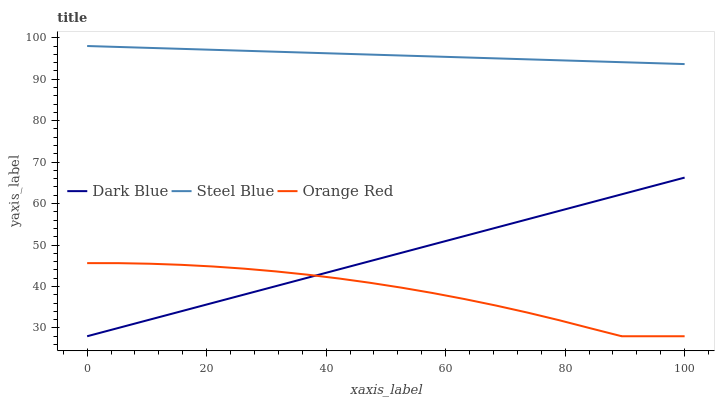Does Orange Red have the minimum area under the curve?
Answer yes or no. Yes. Does Steel Blue have the maximum area under the curve?
Answer yes or no. Yes. Does Steel Blue have the minimum area under the curve?
Answer yes or no. No. Does Orange Red have the maximum area under the curve?
Answer yes or no. No. Is Steel Blue the smoothest?
Answer yes or no. Yes. Is Orange Red the roughest?
Answer yes or no. Yes. Is Orange Red the smoothest?
Answer yes or no. No. Is Steel Blue the roughest?
Answer yes or no. No. Does Dark Blue have the lowest value?
Answer yes or no. Yes. Does Steel Blue have the lowest value?
Answer yes or no. No. Does Steel Blue have the highest value?
Answer yes or no. Yes. Does Orange Red have the highest value?
Answer yes or no. No. Is Orange Red less than Steel Blue?
Answer yes or no. Yes. Is Steel Blue greater than Orange Red?
Answer yes or no. Yes. Does Dark Blue intersect Orange Red?
Answer yes or no. Yes. Is Dark Blue less than Orange Red?
Answer yes or no. No. Is Dark Blue greater than Orange Red?
Answer yes or no. No. Does Orange Red intersect Steel Blue?
Answer yes or no. No. 